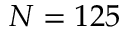<formula> <loc_0><loc_0><loc_500><loc_500>N = 1 2 5</formula> 